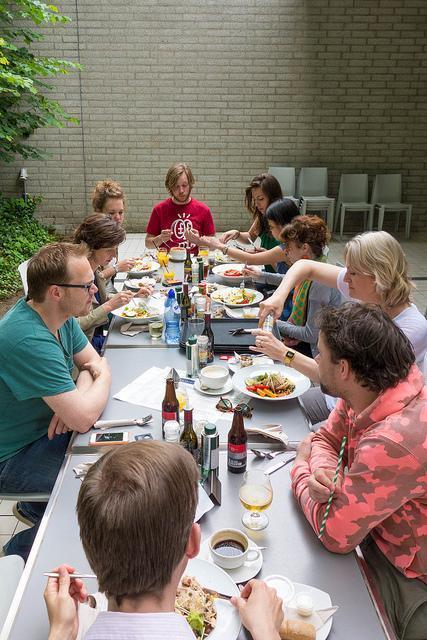How many people are there?
Give a very brief answer. 9. 